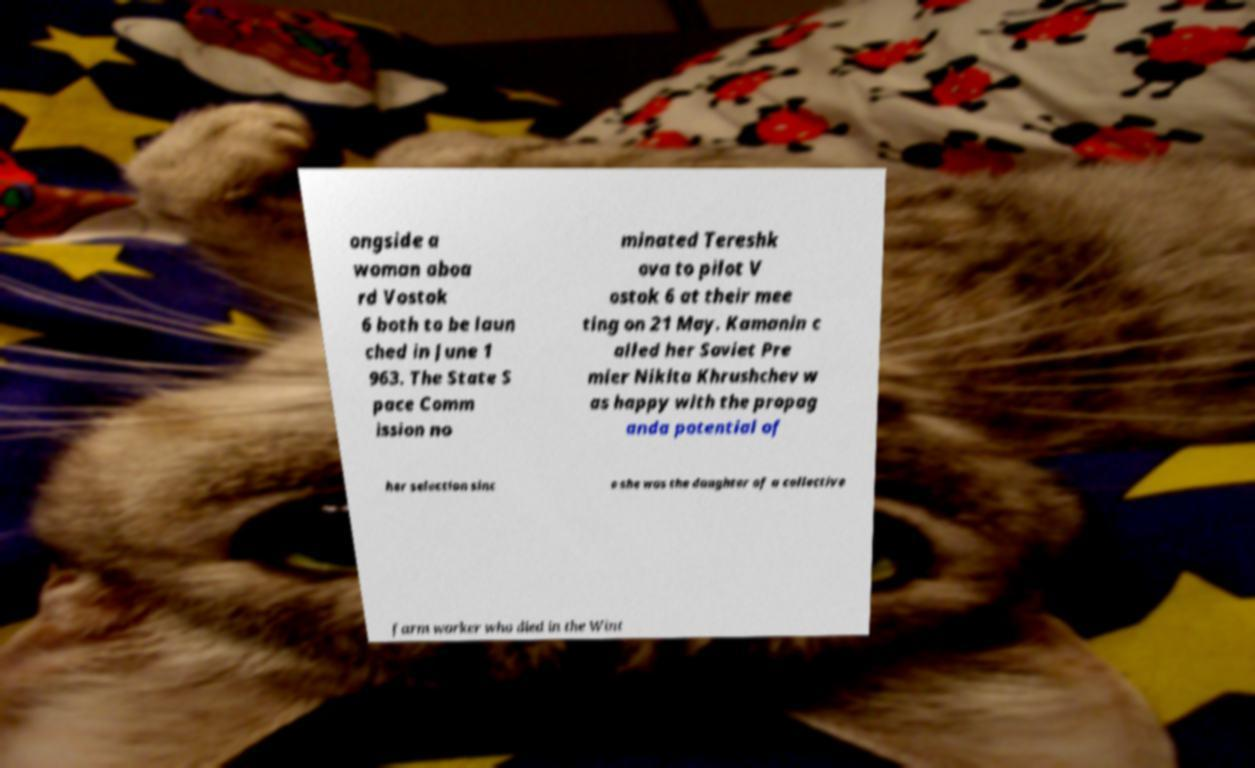I need the written content from this picture converted into text. Can you do that? ongside a woman aboa rd Vostok 6 both to be laun ched in June 1 963. The State S pace Comm ission no minated Tereshk ova to pilot V ostok 6 at their mee ting on 21 May. Kamanin c alled her Soviet Pre mier Nikita Khrushchev w as happy with the propag anda potential of her selection sinc e she was the daughter of a collective farm worker who died in the Wint 